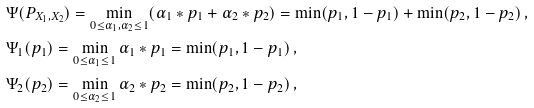<formula> <loc_0><loc_0><loc_500><loc_500>& \Psi ( P _ { X _ { 1 } , X _ { 2 } } ) = \min _ { 0 \leq \alpha _ { 1 } , \alpha _ { 2 } \leq 1 } ( \alpha _ { 1 } * p _ { 1 } + \alpha _ { 2 } * p _ { 2 } ) = \min ( p _ { 1 } , 1 - p _ { 1 } ) + \min ( p _ { 2 } , 1 - p _ { 2 } ) \, , \\ & \Psi _ { 1 } ( p _ { 1 } ) = \min _ { 0 \leq \alpha _ { 1 } \leq 1 } \alpha _ { 1 } * p _ { 1 } = \min ( p _ { 1 } , 1 - p _ { 1 } ) \, , \\ & \Psi _ { 2 } ( p _ { 2 } ) = \min _ { 0 \leq \alpha _ { 2 } \leq 1 } \alpha _ { 2 } * p _ { 2 } = \min ( p _ { 2 } , 1 - p _ { 2 } ) \, ,</formula> 